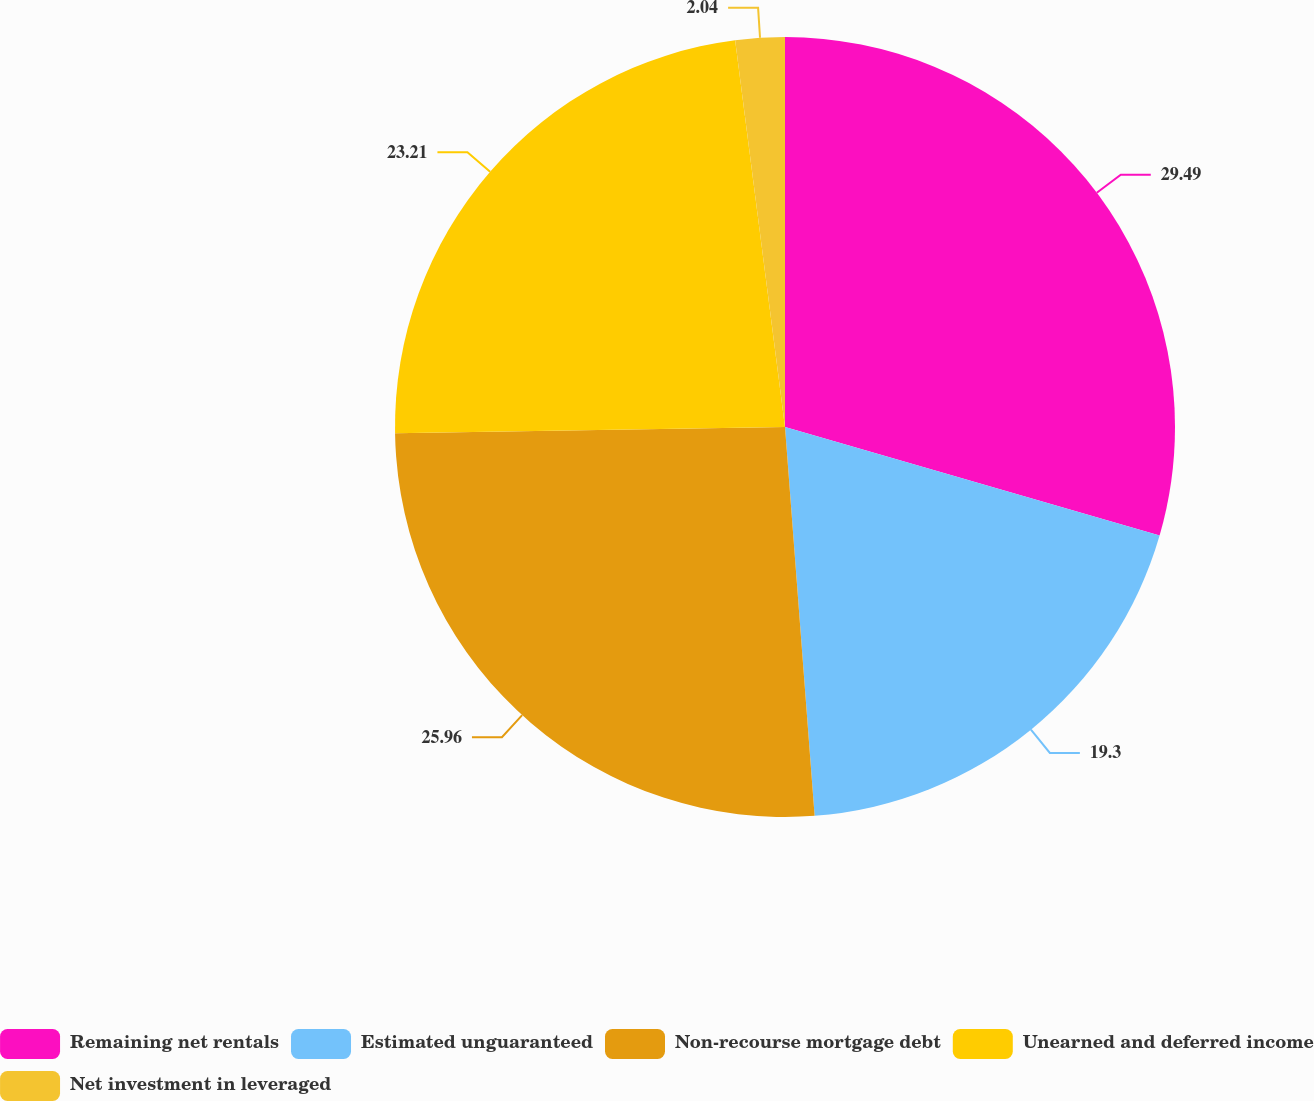Convert chart to OTSL. <chart><loc_0><loc_0><loc_500><loc_500><pie_chart><fcel>Remaining net rentals<fcel>Estimated unguaranteed<fcel>Non-recourse mortgage debt<fcel>Unearned and deferred income<fcel>Net investment in leveraged<nl><fcel>29.49%<fcel>19.3%<fcel>25.96%<fcel>23.21%<fcel>2.04%<nl></chart> 